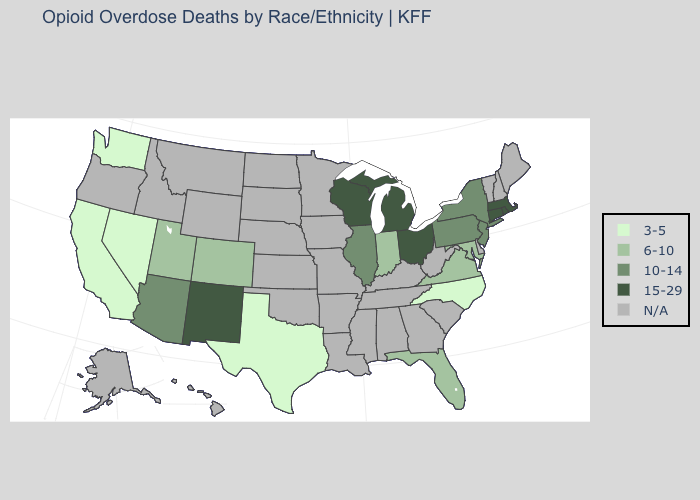Among the states that border Vermont , which have the lowest value?
Be succinct. New York. Name the states that have a value in the range 3-5?
Keep it brief. California, Nevada, North Carolina, Texas, Washington. Does the first symbol in the legend represent the smallest category?
Short answer required. Yes. Does the first symbol in the legend represent the smallest category?
Short answer required. Yes. What is the highest value in the West ?
Keep it brief. 15-29. Among the states that border Pennsylvania , does Maryland have the lowest value?
Answer briefly. Yes. Name the states that have a value in the range 10-14?
Give a very brief answer. Arizona, Illinois, New Jersey, New York, Pennsylvania. What is the value of Arizona?
Keep it brief. 10-14. What is the lowest value in the West?
Be succinct. 3-5. Name the states that have a value in the range 10-14?
Quick response, please. Arizona, Illinois, New Jersey, New York, Pennsylvania. What is the highest value in the Northeast ?
Answer briefly. 15-29. What is the lowest value in states that border New Mexico?
Short answer required. 3-5. What is the highest value in states that border Minnesota?
Be succinct. 15-29. 